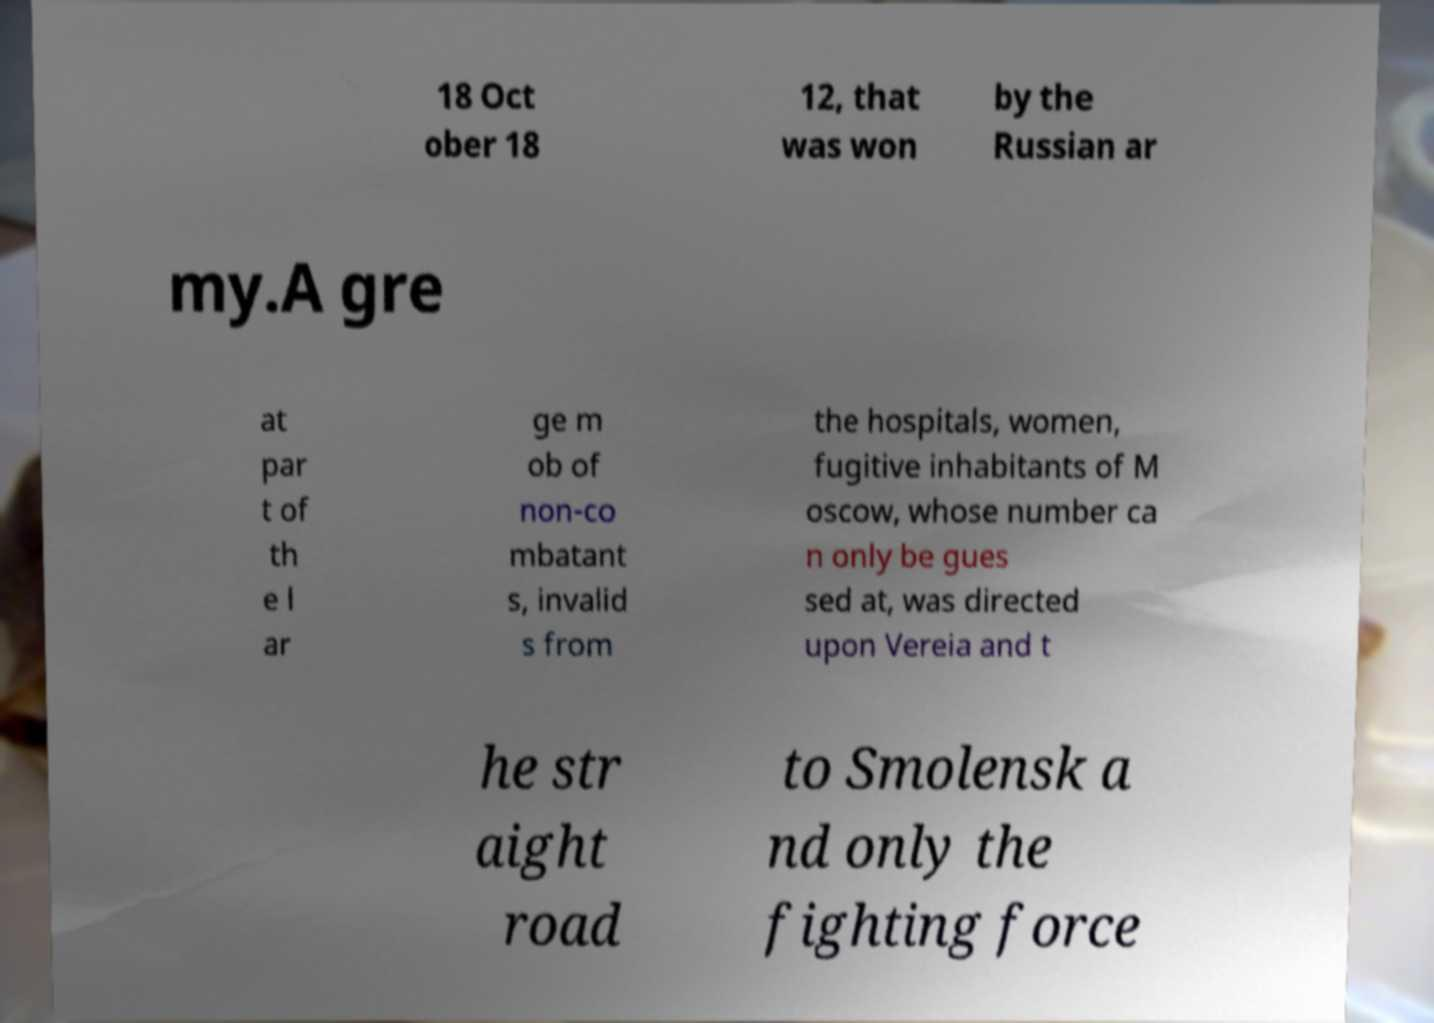Can you accurately transcribe the text from the provided image for me? 18 Oct ober 18 12, that was won by the Russian ar my.A gre at par t of th e l ar ge m ob of non-co mbatant s, invalid s from the hospitals, women, fugitive inhabitants of M oscow, whose number ca n only be gues sed at, was directed upon Vereia and t he str aight road to Smolensk a nd only the fighting force 